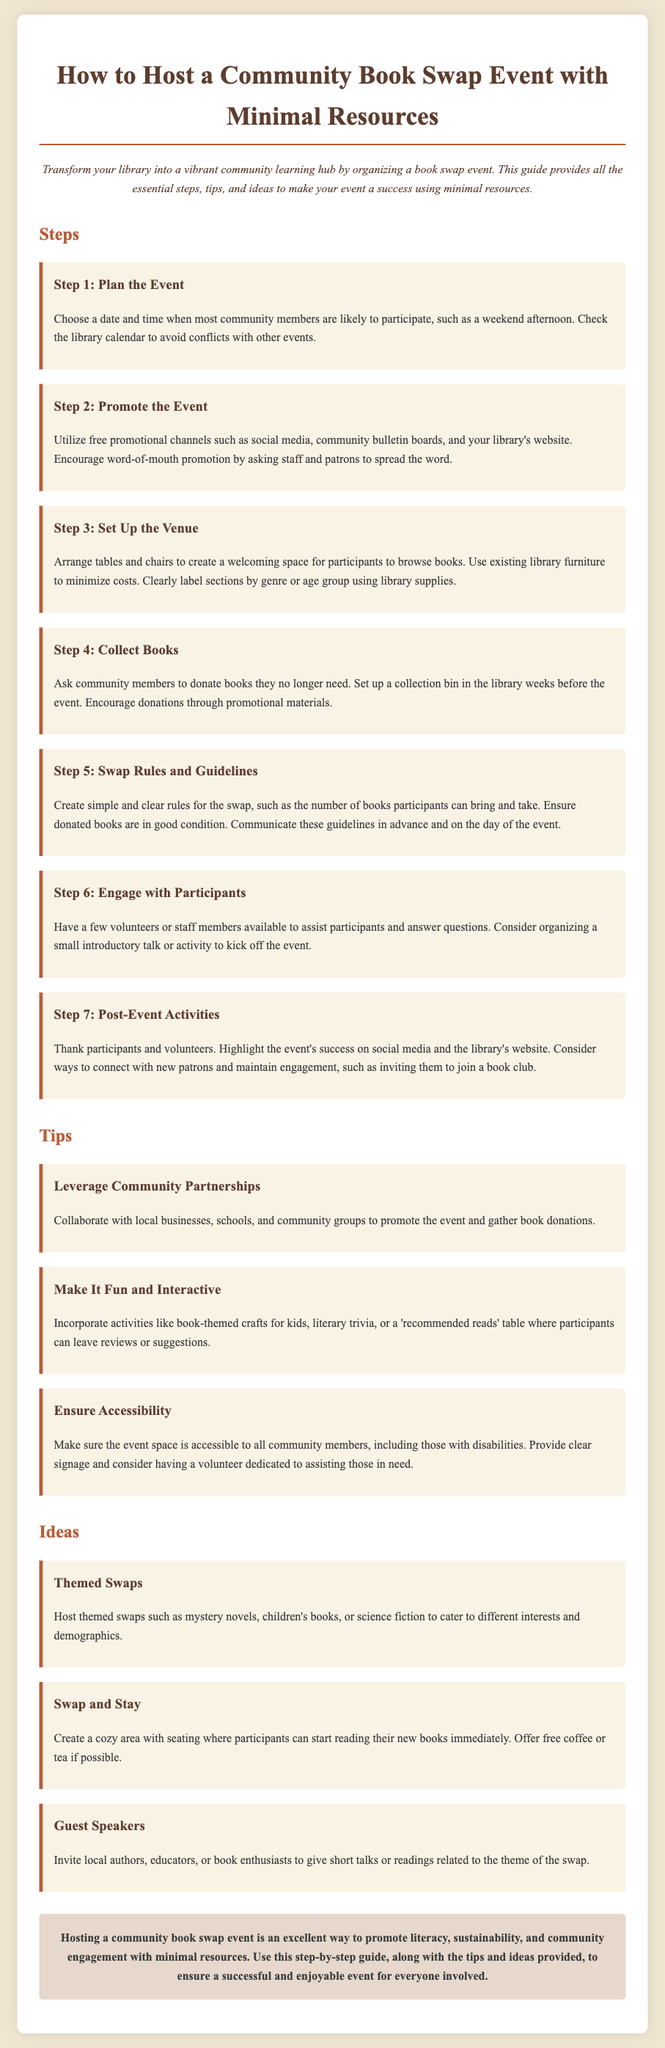what is the title of the document? The title is stated in the `<h1>` tag at the top of the document, which indicates the main topic discussed.
Answer: How to Host a Community Book Swap Event with Minimal Resources how many steps are outlined for the event? The number of steps can be determined by counting the sections under "Steps" in the document.
Answer: 7 what should participants do with books they no longer need? This can be found in the section that discusses collecting books for the event, which gives specific guidance on what to do with unwanted books.
Answer: Donate which day type is suggested for hosting the event? The suggestion can be found in the first step regarding planning the event and when to have the event for maximum participation.
Answer: Weekend what is one way to promote the book swap event? This information can be gathered from the section on promoting the event, highlighting effective methods to reach out to the community.
Answer: Social media what activity can be included to engage children during the event? The tip about making the event fun and interactive provides specific activities geared towards children.
Answer: Book-themed crafts what is a suggested post-event activity? This is mentioned towards the end as a way to maintain engagement after the event is over.
Answer: Thank participants how can local resources be leveraged for the event? The tips provided discuss potential collaborations that can enhance the event's reach and effectiveness.
Answer: Partnerships 